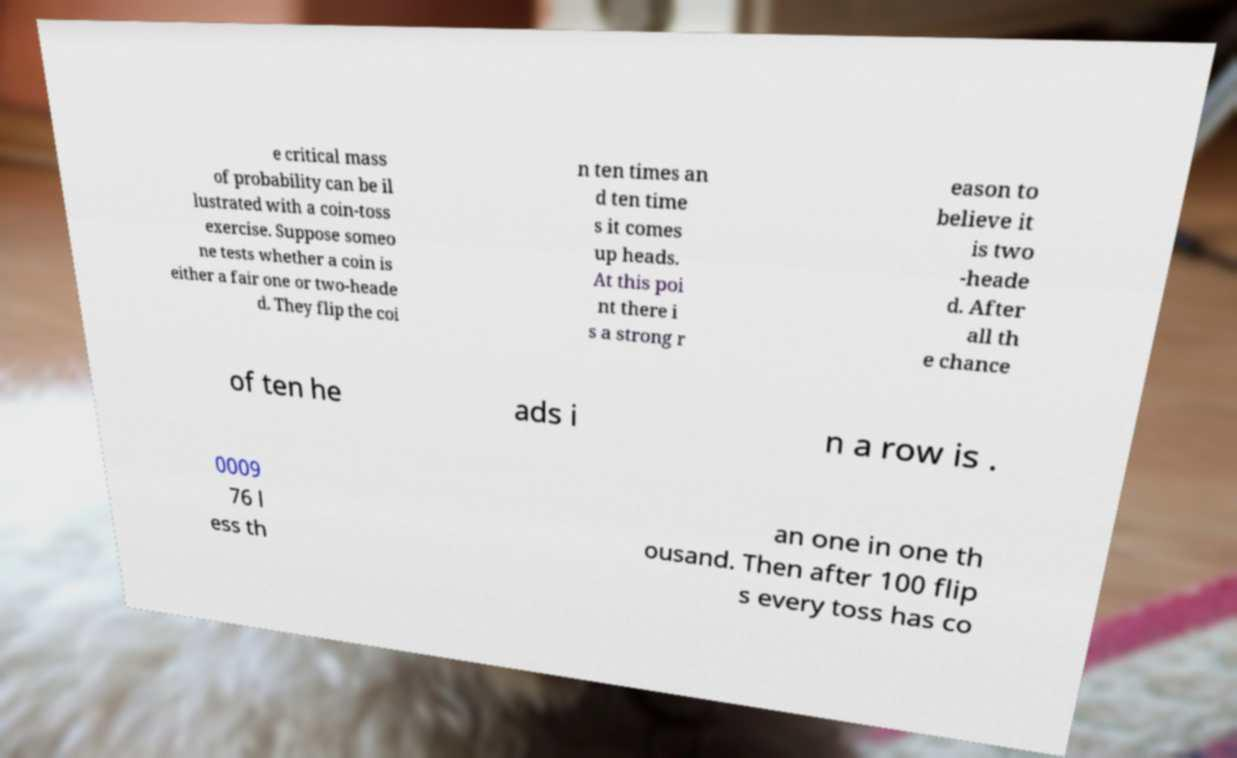What messages or text are displayed in this image? I need them in a readable, typed format. e critical mass of probability can be il lustrated with a coin-toss exercise. Suppose someo ne tests whether a coin is either a fair one or two-heade d. They flip the coi n ten times an d ten time s it comes up heads. At this poi nt there i s a strong r eason to believe it is two -heade d. After all th e chance of ten he ads i n a row is . 0009 76 l ess th an one in one th ousand. Then after 100 flip s every toss has co 